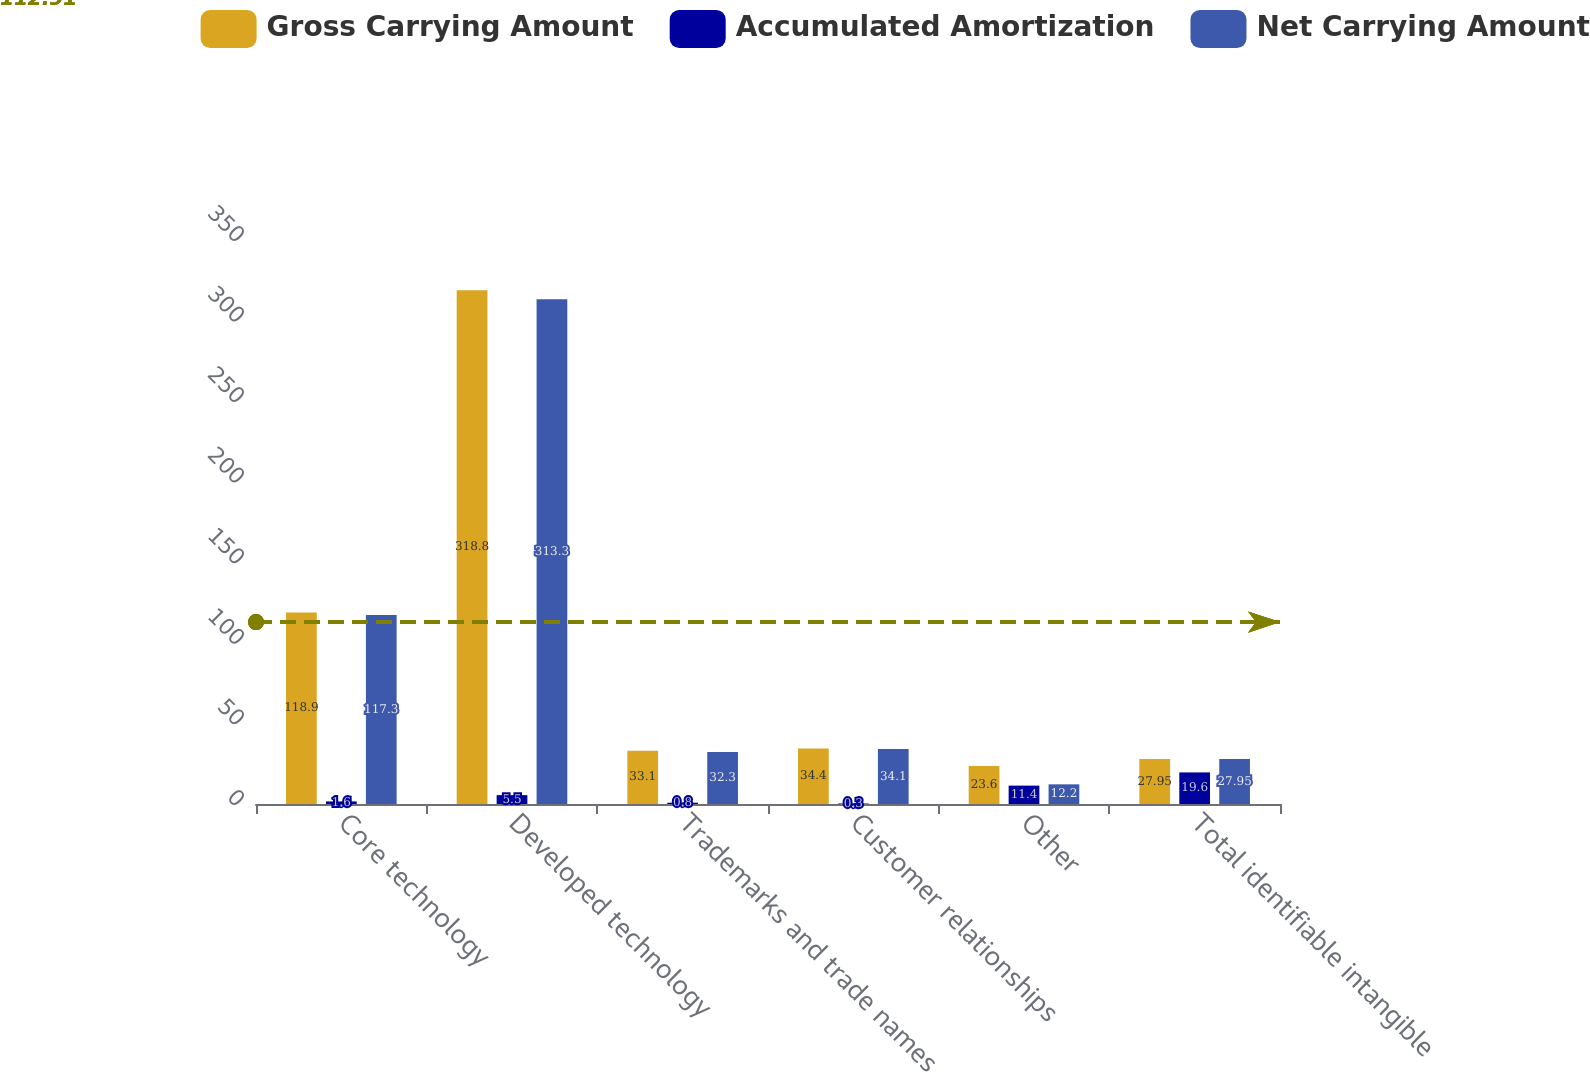Convert chart. <chart><loc_0><loc_0><loc_500><loc_500><stacked_bar_chart><ecel><fcel>Core technology<fcel>Developed technology<fcel>Trademarks and trade names<fcel>Customer relationships<fcel>Other<fcel>Total identifiable intangible<nl><fcel>Gross Carrying Amount<fcel>118.9<fcel>318.8<fcel>33.1<fcel>34.4<fcel>23.6<fcel>27.95<nl><fcel>Accumulated Amortization<fcel>1.6<fcel>5.5<fcel>0.8<fcel>0.3<fcel>11.4<fcel>19.6<nl><fcel>Net Carrying Amount<fcel>117.3<fcel>313.3<fcel>32.3<fcel>34.1<fcel>12.2<fcel>27.95<nl></chart> 